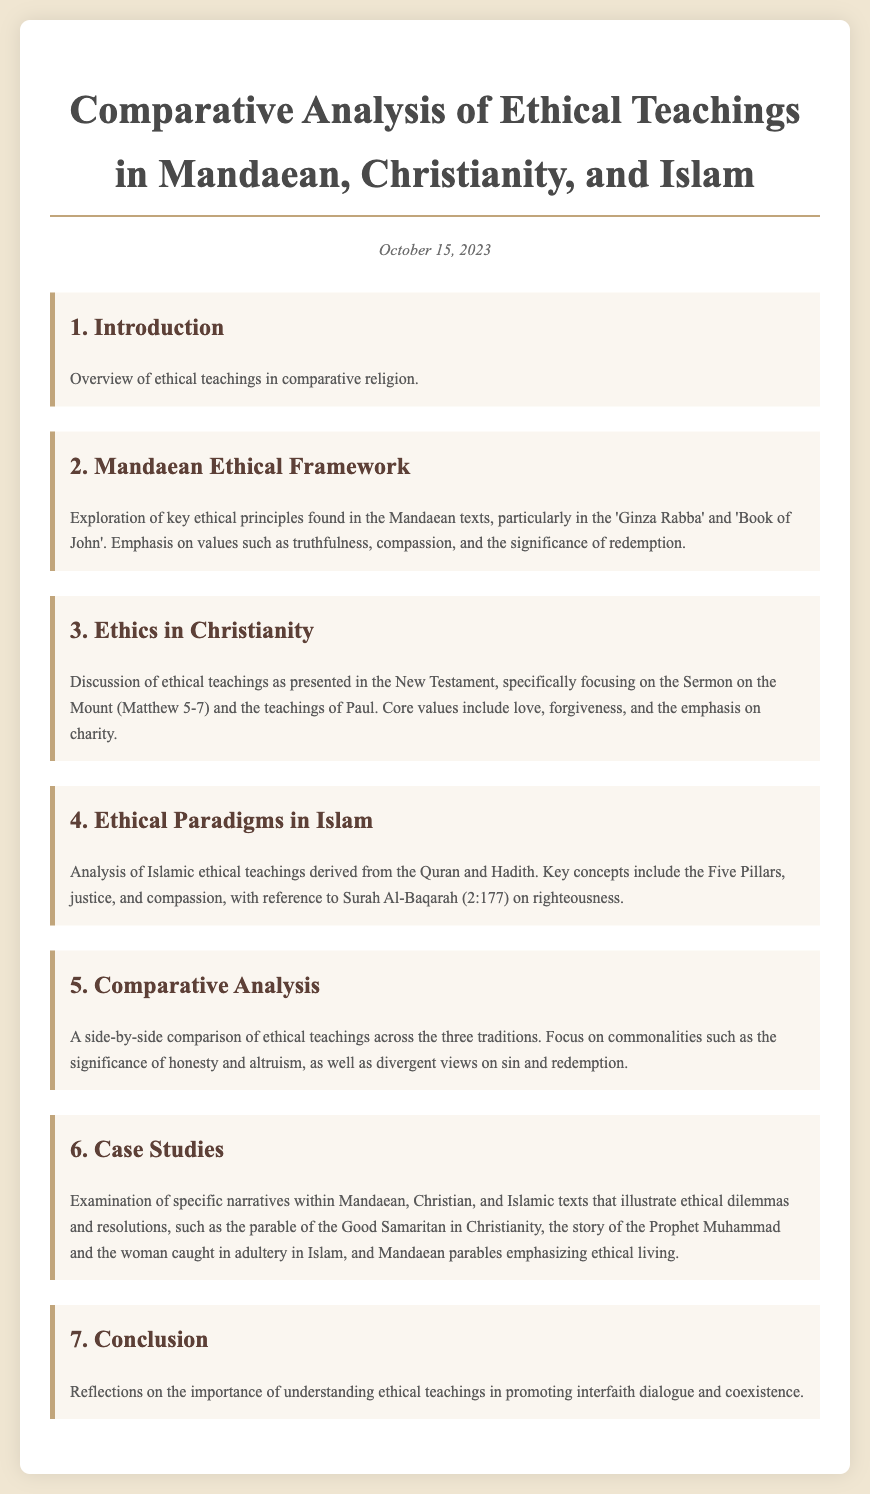What is the date of the agenda? The date provided in the document is October 15, 2023.
Answer: October 15, 2023 What is the title of the first agenda item? The title of the first agenda item is "Introduction."
Answer: Introduction Which Mandaean text is emphasized for ethical principles? The document highlights the 'Ginza Rabba' as a key Mandaean text for ethical principles.
Answer: Ginza Rabba What key ethical value is mentioned in Christianity? The document states that a core value in Christianity is love.
Answer: love Which Surah is referred to in discussing Islamic ethical teachings? Surah Al-Baqarah (2:177) is referenced for discussing Islamic ethical teachings.
Answer: Al-Baqarah (2:177) How many key ethical teachings are examined in the case studies section? There are three key ethical teachings examined in the case studies section.
Answer: three What is a commonality mentioned between the three traditions? The document notes that honesty is a commonality among the traditions.
Answer: honesty What ethical concept is highlighted for Mandaeans in the document? The significance of redemption is highlighted for Mandaeans.
Answer: redemption 